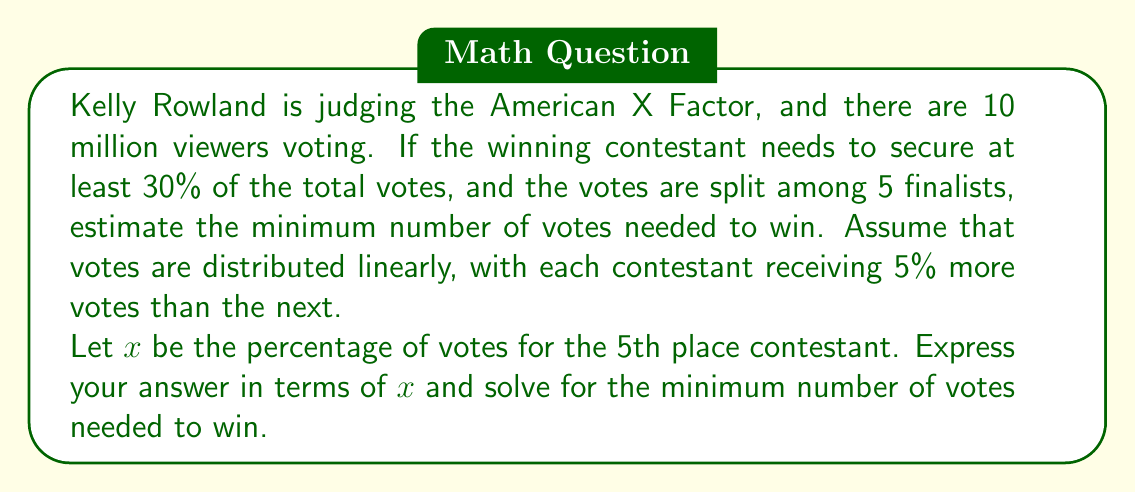Could you help me with this problem? Let's approach this step-by-step:

1) We know there are 5 finalists, and each receives 5% more votes than the next. We can express this as:

   5th place: $x$
   4th place: $x + 5$
   3rd place: $x + 10$
   2nd place: $x + 15$
   1st place: $x + 20$

2) The sum of all percentages must equal 100%:

   $$(x) + (x+5) + (x+10) + (x+15) + (x+20) = 100$$

3) Simplify the equation:

   $$5x + 50 = 100$$
   $$5x = 50$$
   $$x = 10$$

4) So, the 5th place contestant receives 10% of the votes, and the 1st place (winner) receives $10 + 20 = 30$% of the votes.

5) To win, a contestant needs at least 30% of the total votes.

6) With 10 million total voters, 30% is:

   $$30\% \text{ of } 10,000,000 = 0.30 \times 10,000,000 = 3,000,000$$

Therefore, the minimum number of votes needed to win is 3,000,000.
Answer: 3,000,000 votes 